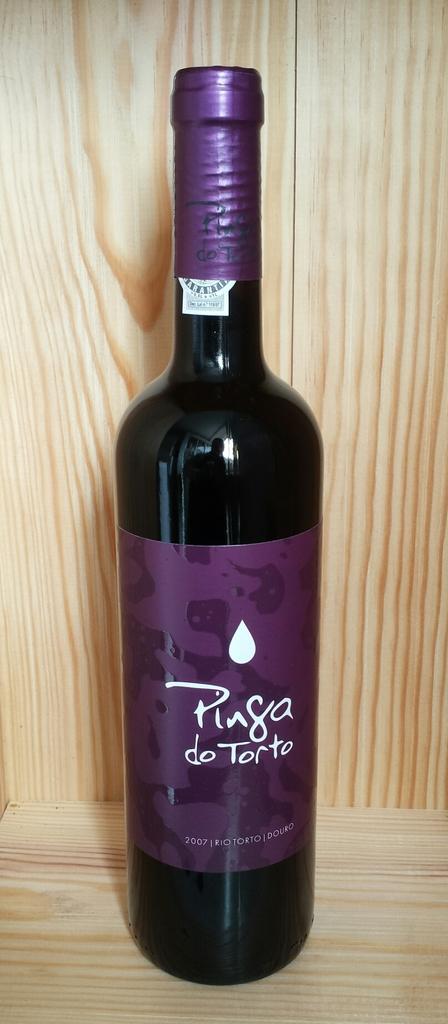Was this made in 2007?
Your response must be concise. Yes. 